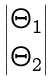<formula> <loc_0><loc_0><loc_500><loc_500>\begin{vmatrix} \Theta _ { 1 } \\ \Theta _ { 2 } \end{vmatrix}</formula> 